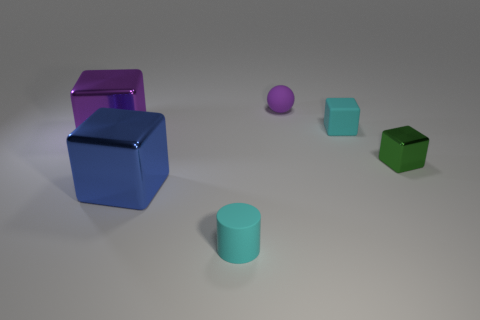There is a tiny matte thing that is the same color as the tiny rubber cylinder; what is its shape?
Give a very brief answer. Cube. What is the size of the cyan thing that is the same shape as the blue metal thing?
Offer a terse response. Small. Do the purple object on the right side of the cyan rubber cylinder and the large blue thing have the same shape?
Ensure brevity in your answer.  No. There is a metallic block in front of the small green metallic cube; what is its color?
Ensure brevity in your answer.  Blue. How many other things are there of the same size as the cyan matte cylinder?
Provide a succinct answer. 3. Is there any other thing that is the same shape as the purple matte thing?
Provide a succinct answer. No. Is the number of tiny purple spheres that are left of the tiny matte sphere the same as the number of purple rubber things?
Offer a very short reply. No. How many tiny spheres have the same material as the blue object?
Your answer should be very brief. 0. What color is the cylinder that is the same material as the purple ball?
Provide a succinct answer. Cyan. Does the tiny green shiny object have the same shape as the big blue thing?
Your answer should be very brief. Yes. 